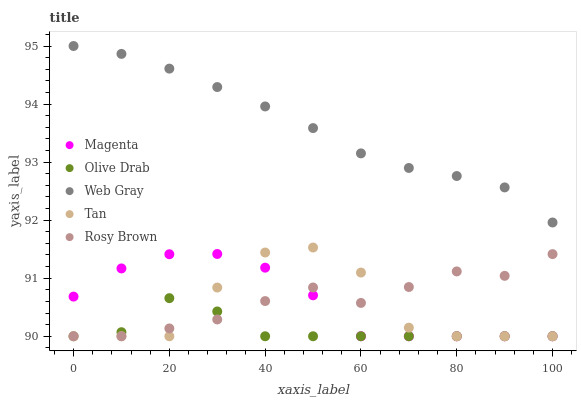Does Olive Drab have the minimum area under the curve?
Answer yes or no. Yes. Does Web Gray have the maximum area under the curve?
Answer yes or no. Yes. Does Rosy Brown have the minimum area under the curve?
Answer yes or no. No. Does Rosy Brown have the maximum area under the curve?
Answer yes or no. No. Is Web Gray the smoothest?
Answer yes or no. Yes. Is Tan the roughest?
Answer yes or no. Yes. Is Rosy Brown the smoothest?
Answer yes or no. No. Is Rosy Brown the roughest?
Answer yes or no. No. Does Magenta have the lowest value?
Answer yes or no. Yes. Does Web Gray have the lowest value?
Answer yes or no. No. Does Web Gray have the highest value?
Answer yes or no. Yes. Does Rosy Brown have the highest value?
Answer yes or no. No. Is Tan less than Web Gray?
Answer yes or no. Yes. Is Web Gray greater than Tan?
Answer yes or no. Yes. Does Olive Drab intersect Rosy Brown?
Answer yes or no. Yes. Is Olive Drab less than Rosy Brown?
Answer yes or no. No. Is Olive Drab greater than Rosy Brown?
Answer yes or no. No. Does Tan intersect Web Gray?
Answer yes or no. No. 